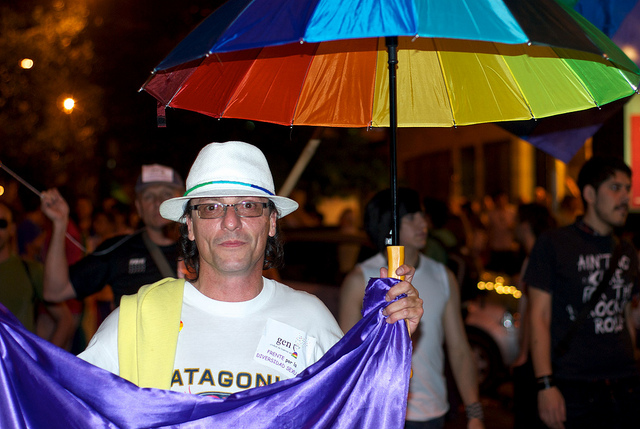Please transcribe the text information in this image. ATAGON 